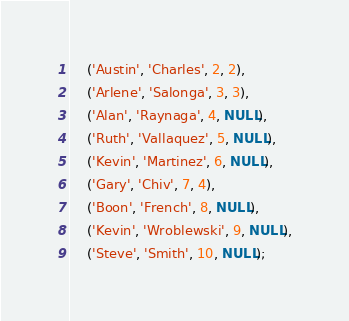Convert code to text. <code><loc_0><loc_0><loc_500><loc_500><_SQL_>    ('Austin', 'Charles', 2, 2),
    ('Arlene', 'Salonga', 3, 3),
    ('Alan', 'Raynaga', 4, NULL),
    ('Ruth', 'Vallaquez', 5, NULL),
    ('Kevin', 'Martinez', 6, NULL),
    ('Gary', 'Chiv', 7, 4),
    ('Boon', 'French', 8, NULL),
    ('Kevin', 'Wroblewski', 9, NULL),
    ('Steve', 'Smith', 10, NULL);
</code> 